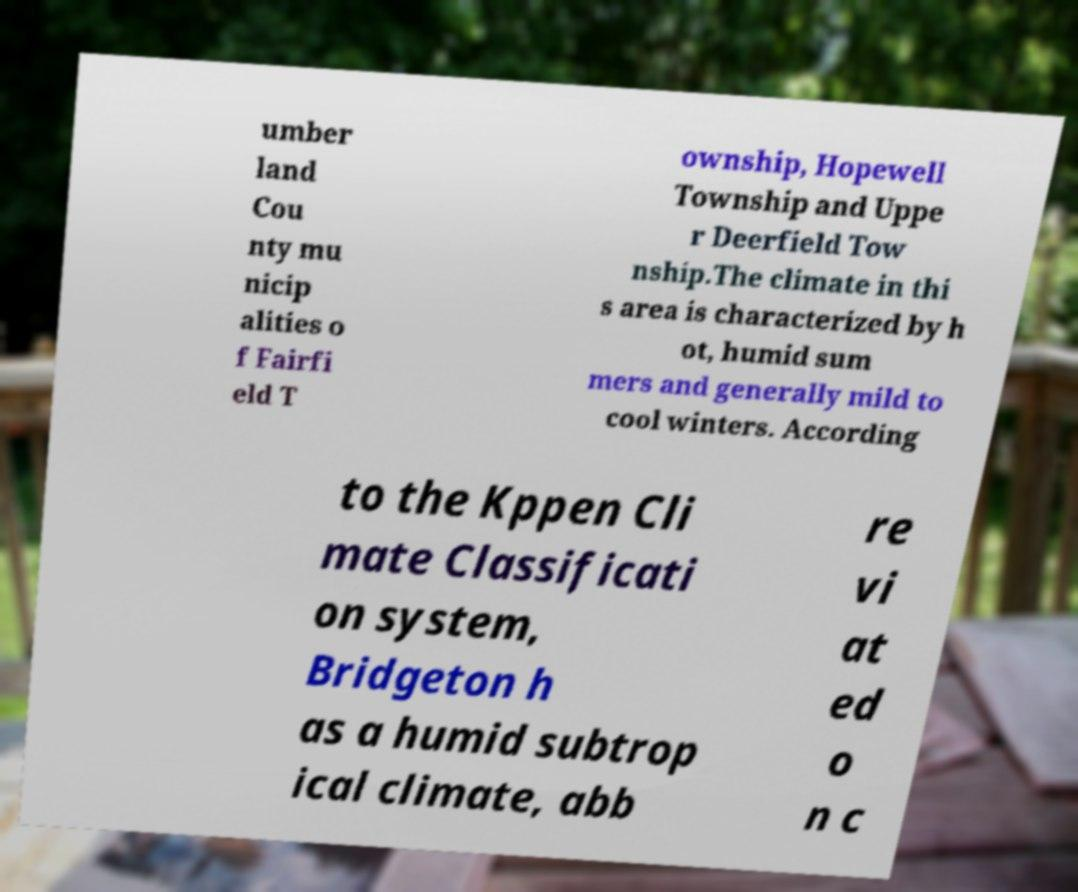Can you read and provide the text displayed in the image?This photo seems to have some interesting text. Can you extract and type it out for me? umber land Cou nty mu nicip alities o f Fairfi eld T ownship, Hopewell Township and Uppe r Deerfield Tow nship.The climate in thi s area is characterized by h ot, humid sum mers and generally mild to cool winters. According to the Kppen Cli mate Classificati on system, Bridgeton h as a humid subtrop ical climate, abb re vi at ed o n c 